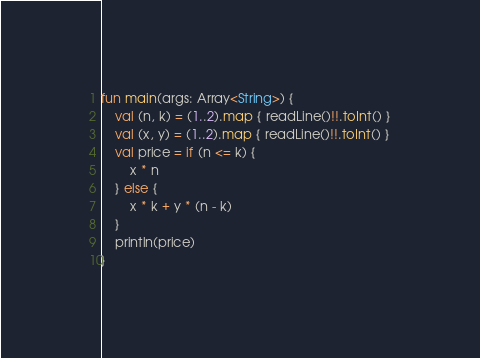<code> <loc_0><loc_0><loc_500><loc_500><_Kotlin_>fun main(args: Array<String>) {
    val (n, k) = (1..2).map { readLine()!!.toInt() }
    val (x, y) = (1..2).map { readLine()!!.toInt() }
    val price = if (n <= k) {
        x * n
    } else {
        x * k + y * (n - k)
    }
    println(price)
}</code> 